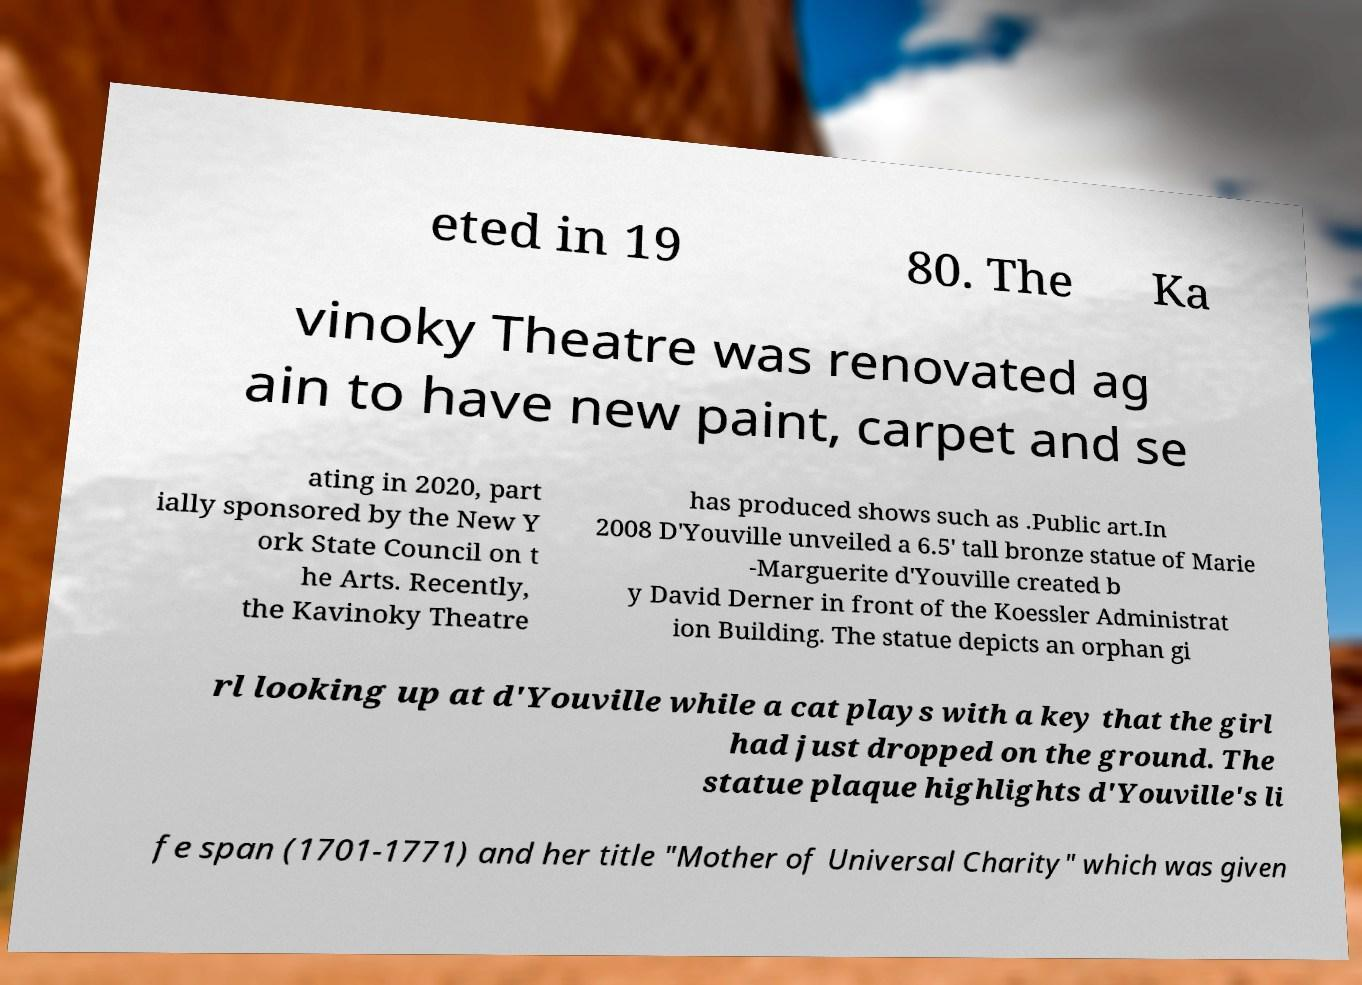There's text embedded in this image that I need extracted. Can you transcribe it verbatim? eted in 19 80. The Ka vinoky Theatre was renovated ag ain to have new paint, carpet and se ating in 2020, part ially sponsored by the New Y ork State Council on t he Arts. Recently, the Kavinoky Theatre has produced shows such as .Public art.In 2008 D'Youville unveiled a 6.5' tall bronze statue of Marie -Marguerite d'Youville created b y David Derner in front of the Koessler Administrat ion Building. The statue depicts an orphan gi rl looking up at d'Youville while a cat plays with a key that the girl had just dropped on the ground. The statue plaque highlights d'Youville's li fe span (1701-1771) and her title "Mother of Universal Charity" which was given 